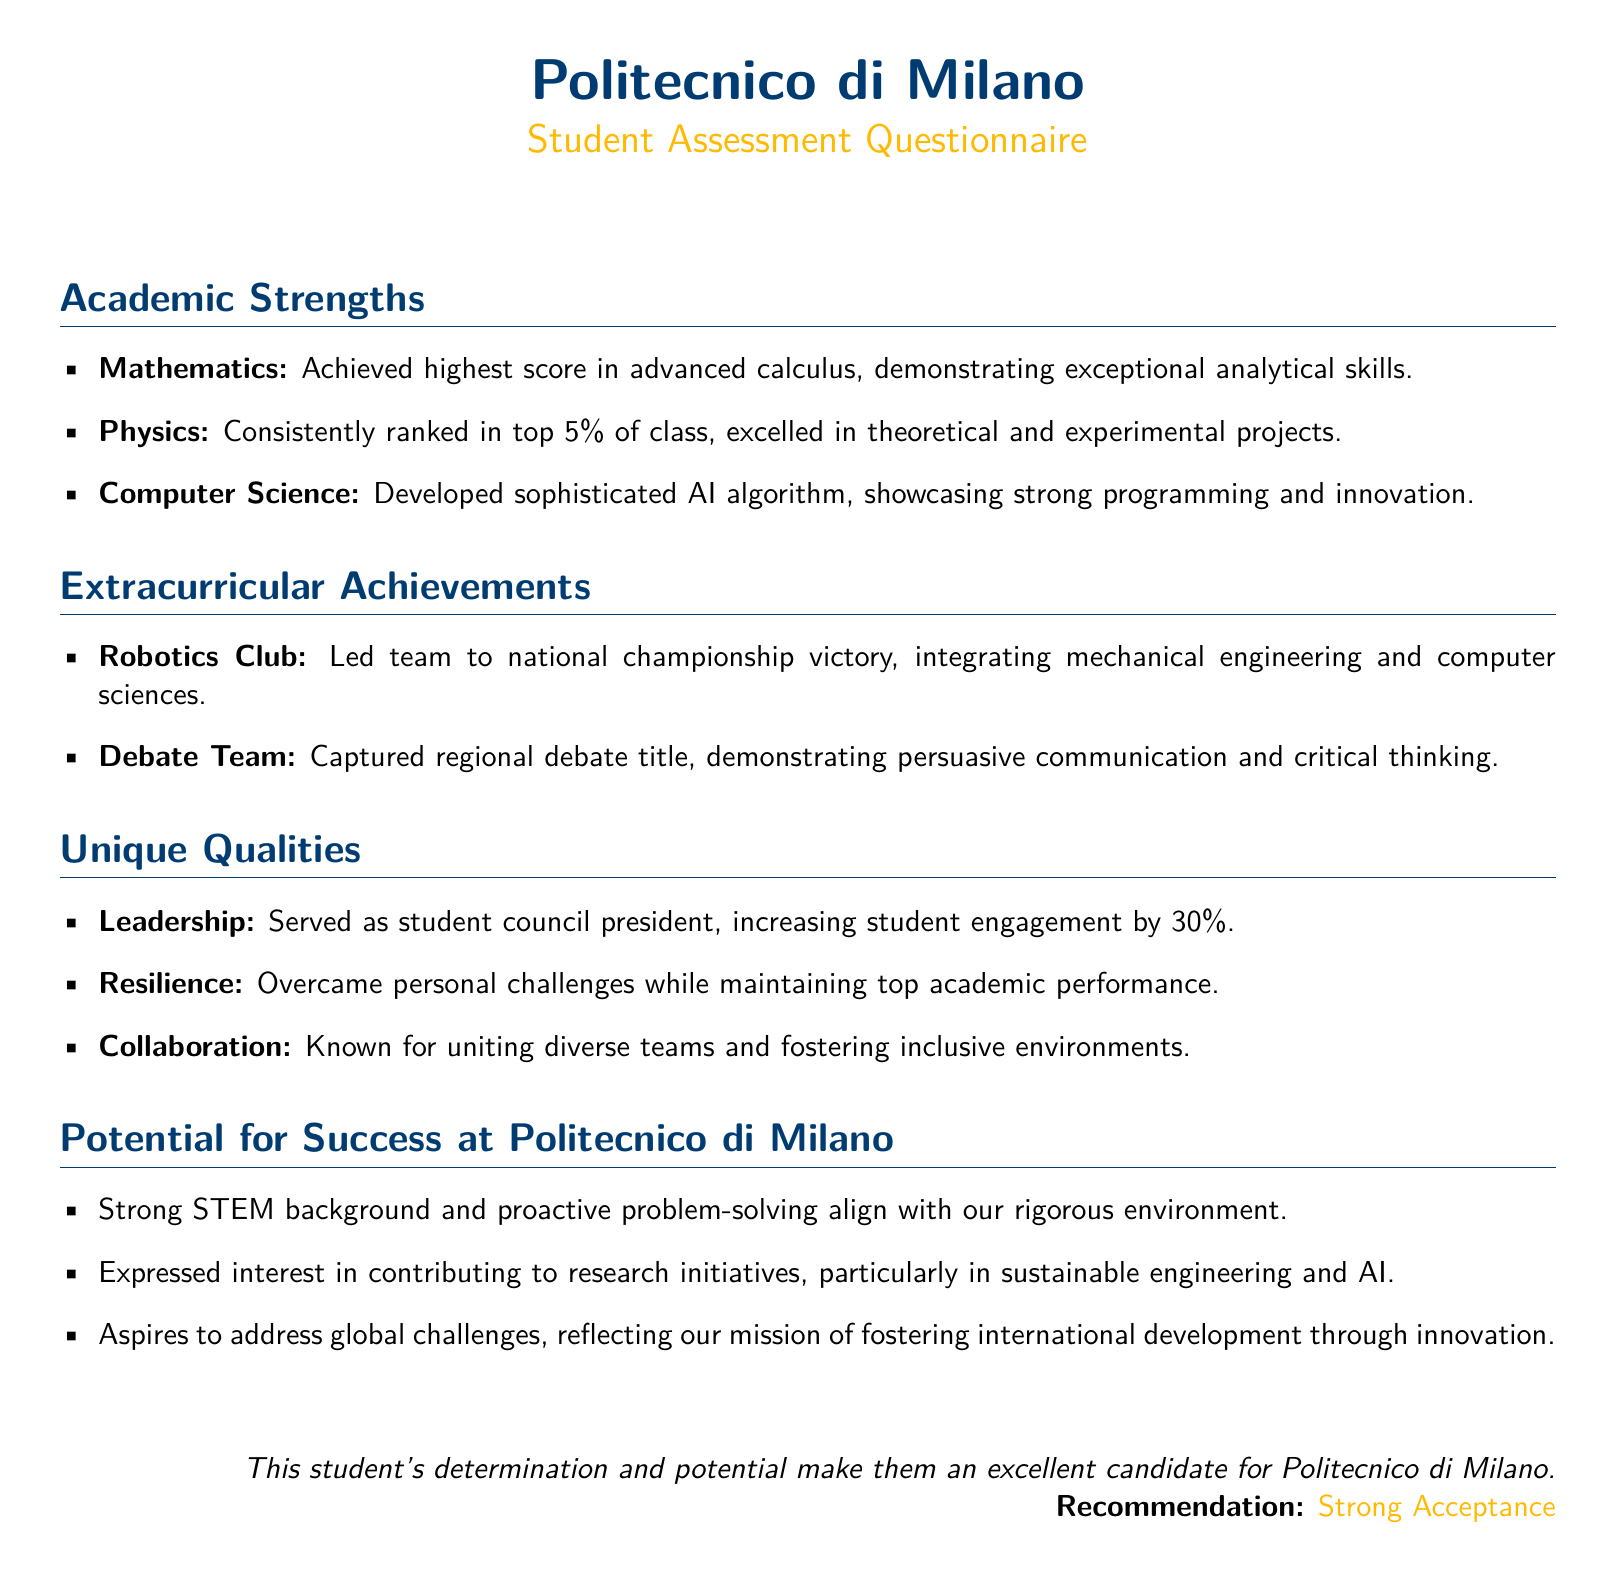What is the student's highest score in mathematics? The document states that the student achieved the highest score in advanced calculus.
Answer: advanced calculus In which extracurricular activity did the student capture a regional title? The document mentions that the student captured a regional debate title as part of the Debate Team.
Answer: Debate Team What percentage of class did the student consistently rank in physics? The document states that the student consistently ranked in the top 5% of the class.
Answer: top 5% Which role did the student serve in the student council? The document notes that the student served as student council president.
Answer: student council president What is one of the student’s expressed interests at Politecnico di Milano? The document mentions that the student expressed interest in contributing to research initiatives, particularly in sustainable engineering and AI.
Answer: sustainable engineering and AI How many students were engaged by the student council president's initiatives? The document states that the student increased student engagement by 30%.
Answer: 30% What does the student's potential for success align with? The document states that the student's strong STEM background and proactive problem-solving align with the rigorous environment at Politecnico di Milano.
Answer: rigorous environment What recommendation is given for the student in the document? The document concludes with a recommendation for strong acceptance of the student.
Answer: Strong Acceptance What is a unique quality mentioned about the student regarding teamwork? The document notes that the student is known for uniting diverse teams and fostering inclusive environments.
Answer: collaboration 